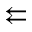Convert formula to latex. <formula><loc_0><loc_0><loc_500><loc_500>\left l e f t a r r o w s</formula> 